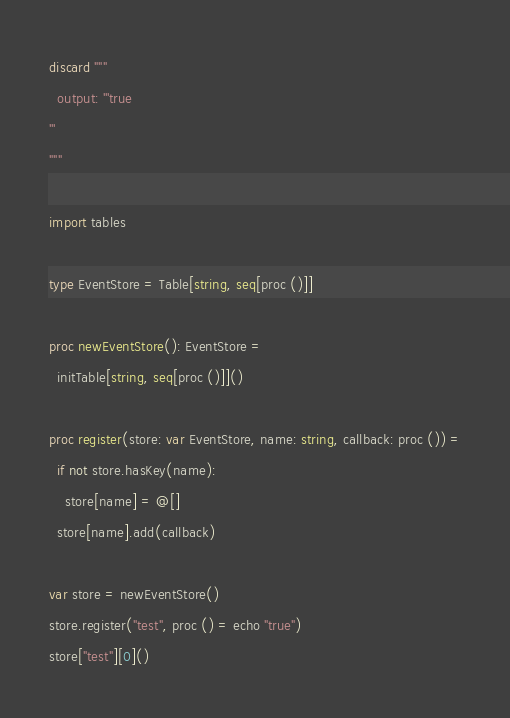Convert code to text. <code><loc_0><loc_0><loc_500><loc_500><_Nim_>discard """
  output: '''true
'''
"""

import tables

type EventStore = Table[string, seq[proc ()]]

proc newEventStore(): EventStore =
  initTable[string, seq[proc ()]]()

proc register(store: var EventStore, name: string, callback: proc ()) =
  if not store.hasKey(name):
    store[name] = @[]
  store[name].add(callback)

var store = newEventStore()
store.register("test", proc () = echo "true")
store["test"][0]()
</code> 